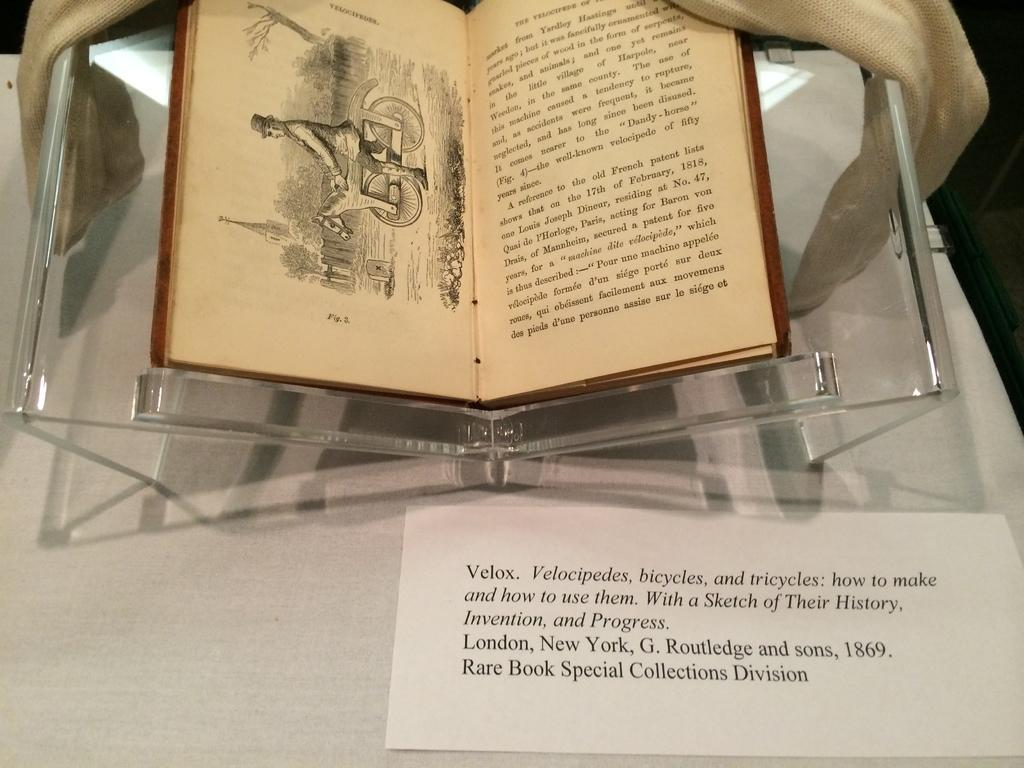<image>
Offer a succinct explanation of the picture presented. a rare book that is open that has white paper by it saying velox 